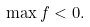Convert formula to latex. <formula><loc_0><loc_0><loc_500><loc_500>\max f < 0 .</formula> 